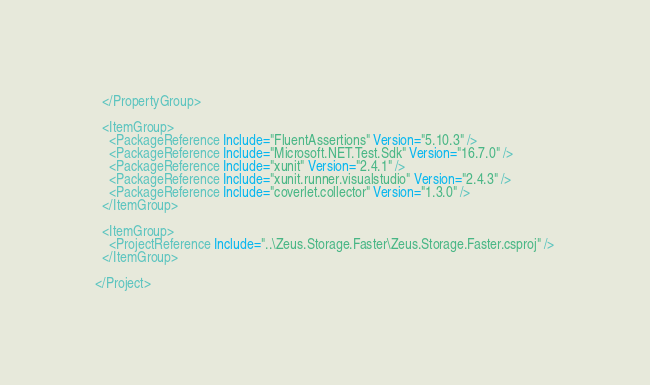Convert code to text. <code><loc_0><loc_0><loc_500><loc_500><_XML_>  </PropertyGroup>

  <ItemGroup>
    <PackageReference Include="FluentAssertions" Version="5.10.3" />
    <PackageReference Include="Microsoft.NET.Test.Sdk" Version="16.7.0" />
    <PackageReference Include="xunit" Version="2.4.1" />
    <PackageReference Include="xunit.runner.visualstudio" Version="2.4.3" />
    <PackageReference Include="coverlet.collector" Version="1.3.0" />
  </ItemGroup>

  <ItemGroup>
    <ProjectReference Include="..\Zeus.Storage.Faster\Zeus.Storage.Faster.csproj" />
  </ItemGroup>

</Project>
</code> 